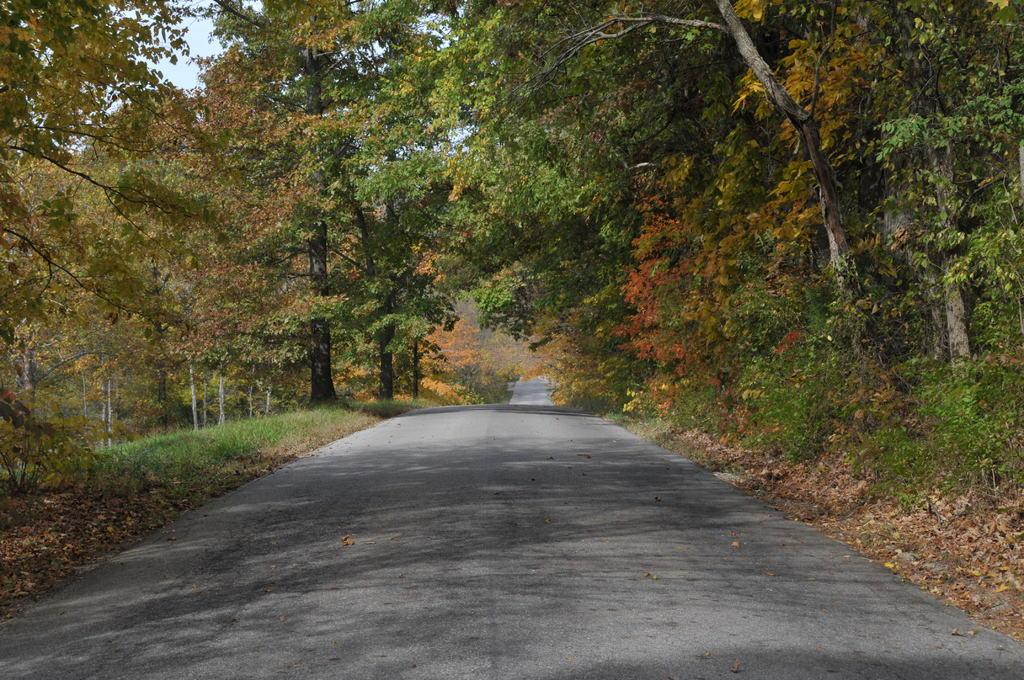What is located in the middle of the image? There is a road in the middle of the image. What type of vegetation is on the right side of the image? There are trees on the right side of the image. What type of vegetation is on the left side of the image? There are trees on the left side of the image. What else can be seen in the image besides the road and trees? There are plants and leaves in the image. What is visible at the top of the image? The sky is visible at the top of the image. What type of wine is being served in the image? There is no wine present in the image; it features a road, trees, plants, and leaves. Can you see any insects flying around the trees in the image? There is no mention of insects in the image, so it cannot be determined if any are present. 